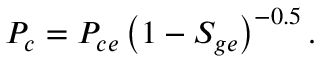Convert formula to latex. <formula><loc_0><loc_0><loc_500><loc_500>P _ { c } = P _ { c e } \left ( 1 - S _ { g e } \right ) ^ { - 0 . 5 } .</formula> 